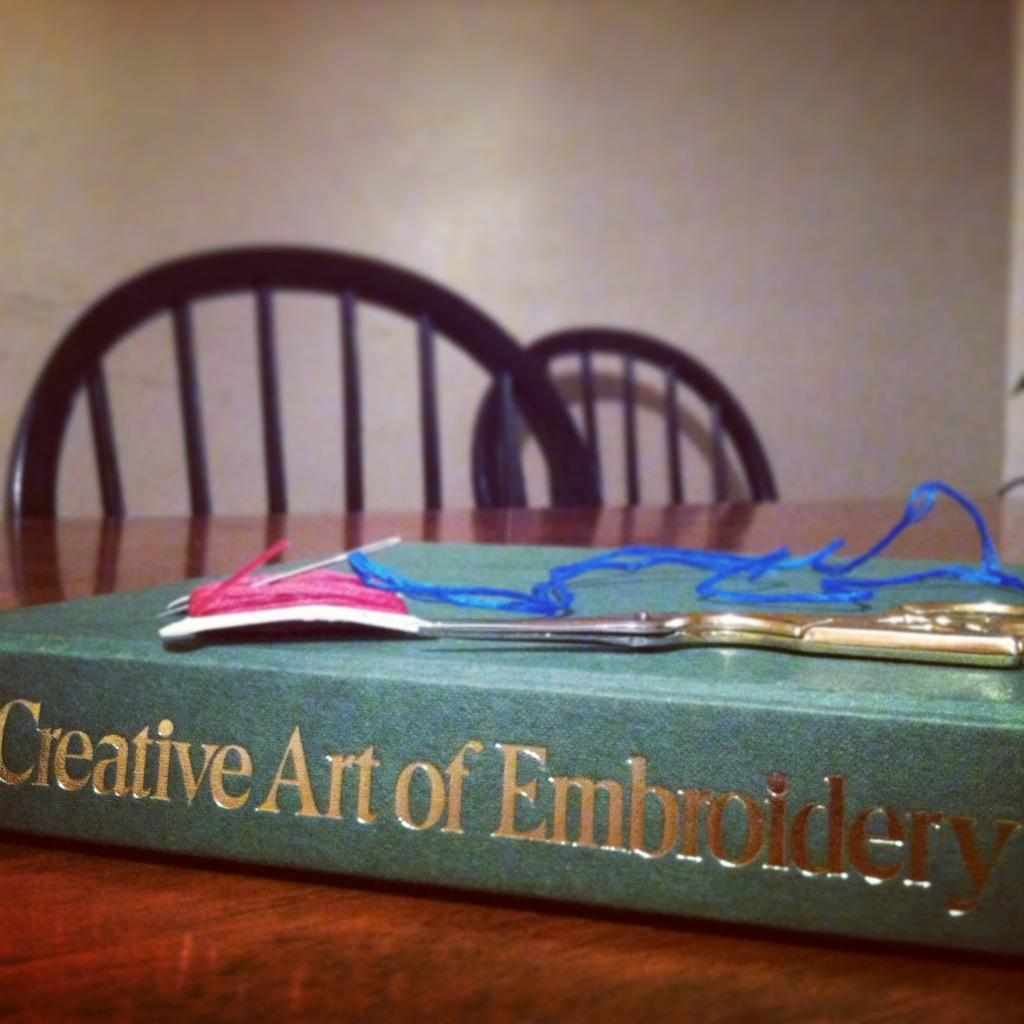<image>
Write a terse but informative summary of the picture. A book called Creative Art of Embroidery sitting on a table. 